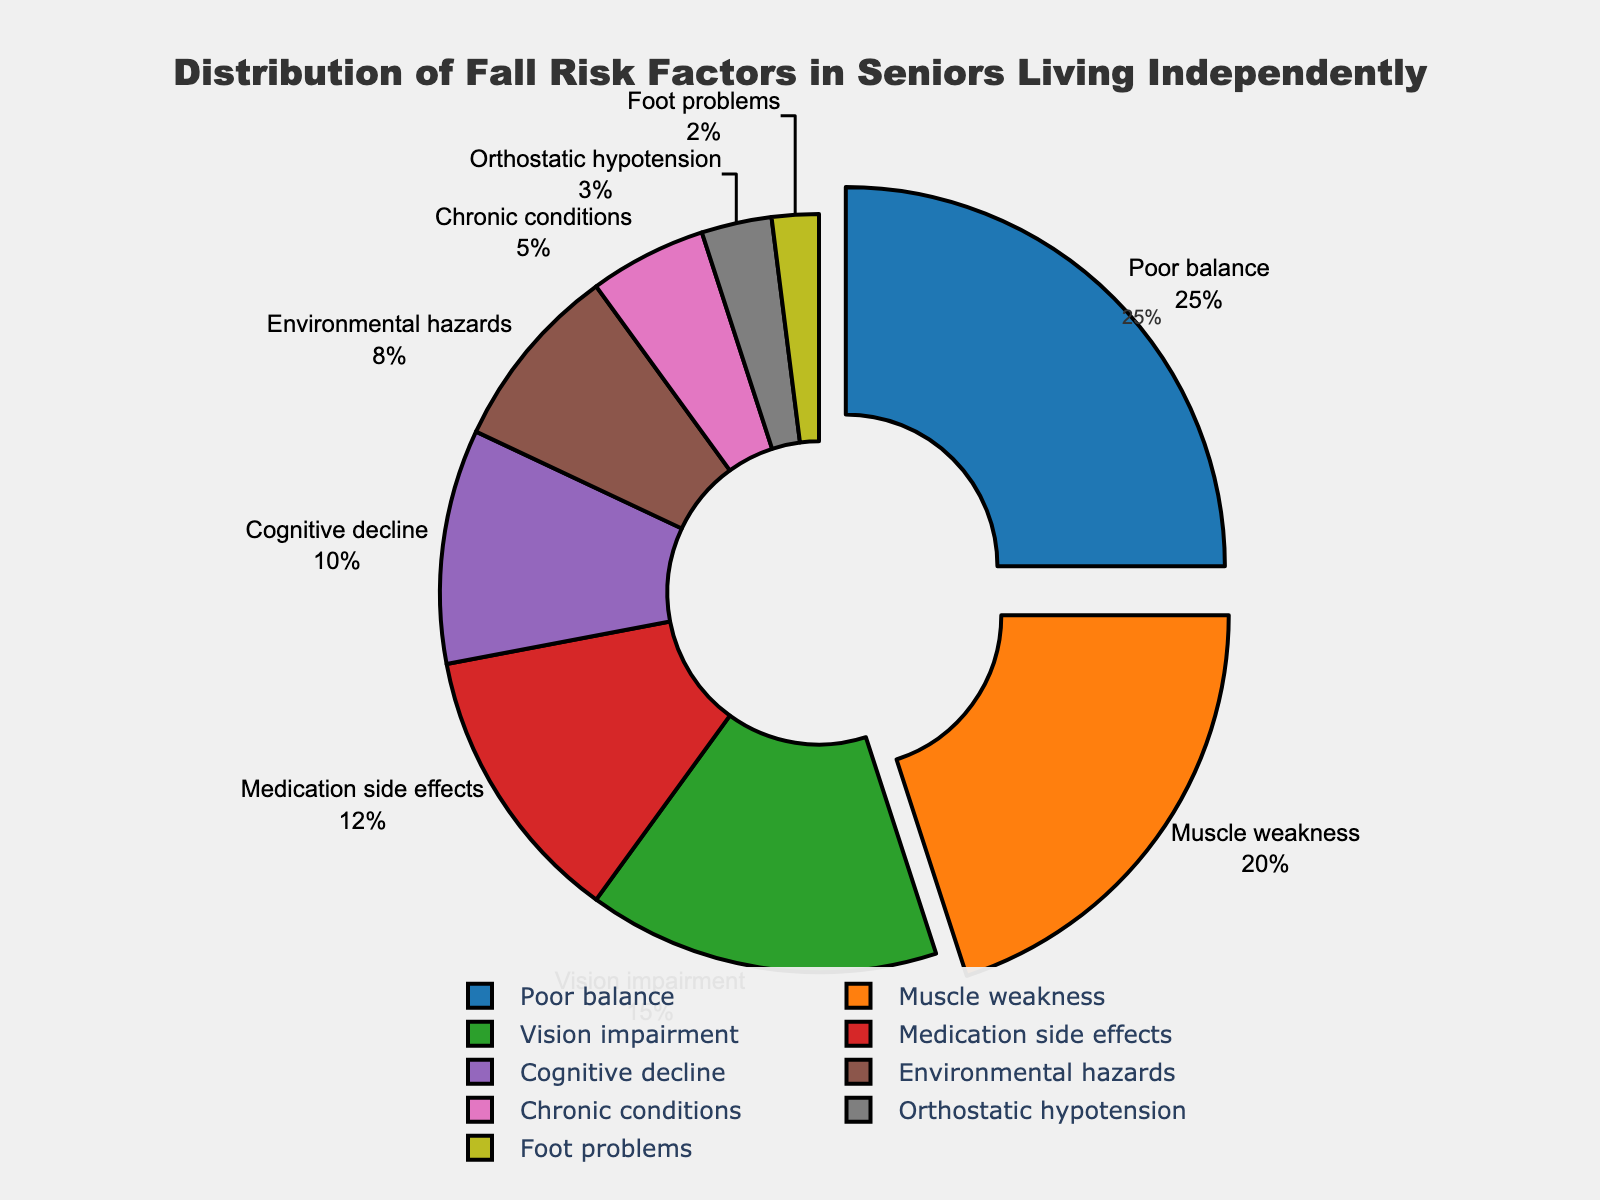what is the total percentage for ‘Medication side effects’ and ‘Cognitive decline’? Both categories are given: Medication side effects is 12% and Cognitive decline is 10%. Adding these together, 12% + 10% = 22%
Answer: 22% Which category has the highest percentage? By looking at the pie chart, the slice labeled ‘Poor balance’ is the largest. The percentage for ‘Poor balance’ is 25%, which is the highest.
Answer: Poor balance Compare the percentages of ‘Muscle weakness’ and ‘Vision impairment’. Which one is larger and by how much? Muscle weakness is shown as 20% and Vision impairment as 15%. The difference is calculated as 20% - 15% = 5%. Therefore, Muscle weakness is larger by 5%.
Answer: Muscle weakness by 5% How many categories have a percentage below 10%? Categories with percentages below 10% as seen in the chart are Environmental hazards (8%), Chronic conditions (5%), Orthostatic hypotension (3%), and Foot problems (2%). This totals to 4 categories.
Answer: 4 What is the percentage difference between the categories 'Environmental hazards' and 'Medication side effects'? Environmental hazards has a percentage of 8% and Medication side effects have 12%. The difference is calculated as 12% - 8% = 4%.
Answer: 4% What percentage of the total does the combination of the three smallest categories represent? The three smallest categories shown are Orthostatic hypotension (3%), Foot problems (2%), and Chronic conditions (5%). Adding these, 3% + 2% + 5% = 10%.
Answer: 10% If you combine the percentages of the two largest categories, do they make up more than 50% of the total? The two largest categories are Poor balance (25%) and Muscle weakness (20%). Adding these together, 25% + 20% = 45%. This does not add up to more than 50%.
Answer: No What color is used to represent the category with the smallest percentage? The category with the smallest percentage, Foot problems at 2%, is represented by a light green color on the pie chart.
Answer: Light green 